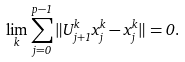Convert formula to latex. <formula><loc_0><loc_0><loc_500><loc_500>\lim _ { k } \sum _ { j = 0 } ^ { p - 1 } \| U _ { j + 1 } ^ { k } x _ { j } ^ { k } - x _ { j } ^ { k } \| = 0 .</formula> 